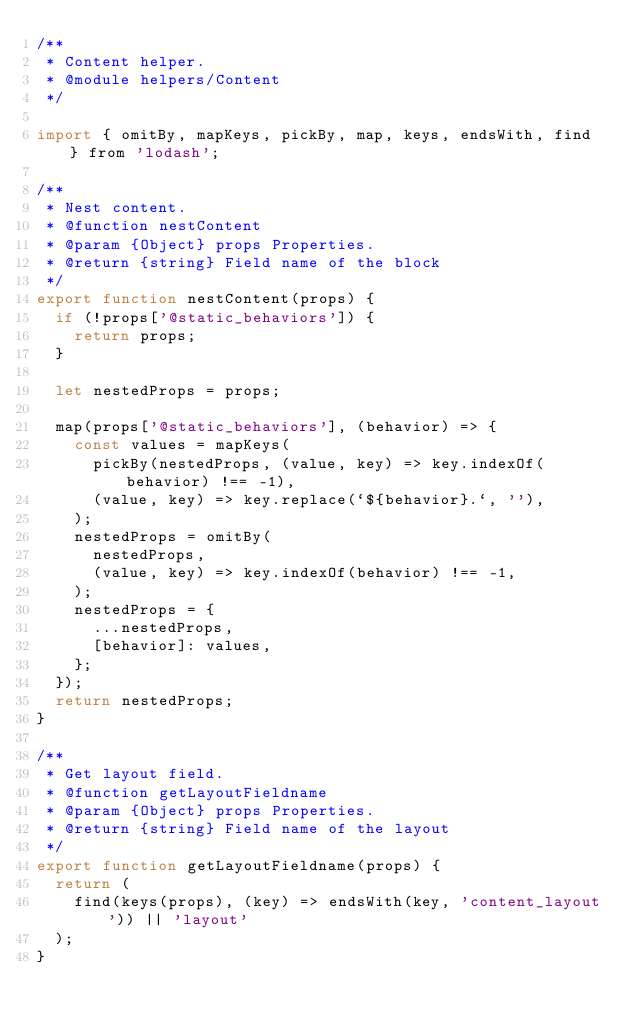<code> <loc_0><loc_0><loc_500><loc_500><_JavaScript_>/**
 * Content helper.
 * @module helpers/Content
 */

import { omitBy, mapKeys, pickBy, map, keys, endsWith, find } from 'lodash';

/**
 * Nest content.
 * @function nestContent
 * @param {Object} props Properties.
 * @return {string} Field name of the block
 */
export function nestContent(props) {
  if (!props['@static_behaviors']) {
    return props;
  }

  let nestedProps = props;

  map(props['@static_behaviors'], (behavior) => {
    const values = mapKeys(
      pickBy(nestedProps, (value, key) => key.indexOf(behavior) !== -1),
      (value, key) => key.replace(`${behavior}.`, ''),
    );
    nestedProps = omitBy(
      nestedProps,
      (value, key) => key.indexOf(behavior) !== -1,
    );
    nestedProps = {
      ...nestedProps,
      [behavior]: values,
    };
  });
  return nestedProps;
}

/**
 * Get layout field.
 * @function getLayoutFieldname
 * @param {Object} props Properties.
 * @return {string} Field name of the layout
 */
export function getLayoutFieldname(props) {
  return (
    find(keys(props), (key) => endsWith(key, 'content_layout')) || 'layout'
  );
}
</code> 